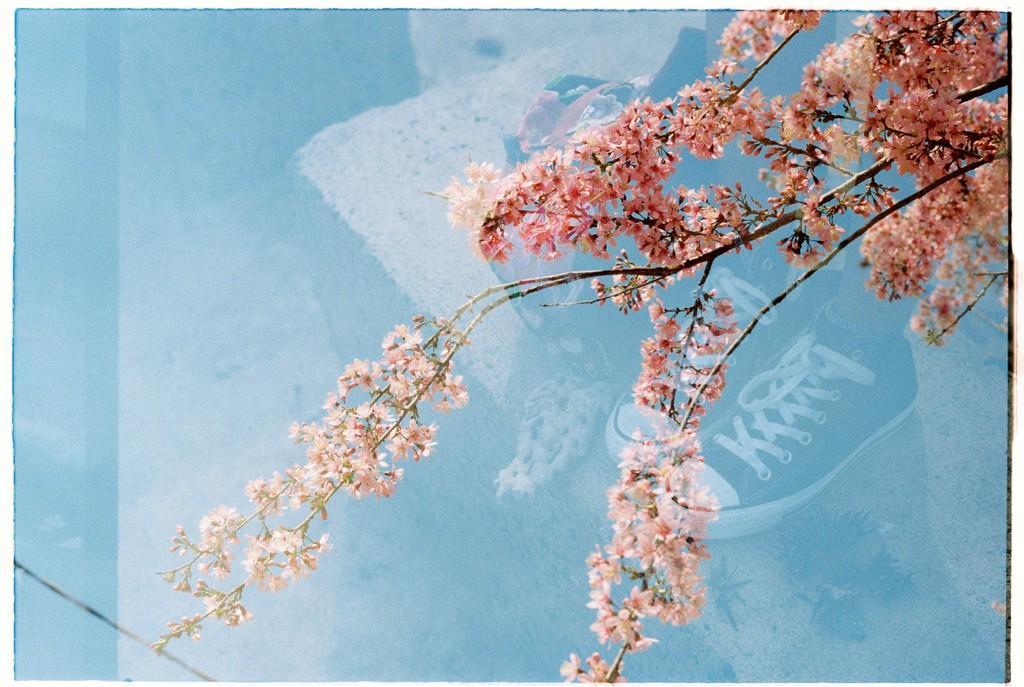Please provide a concise description of this image. In the image we can see there are flowers on the tree and there is a person wearing shoes standing on the ground. 